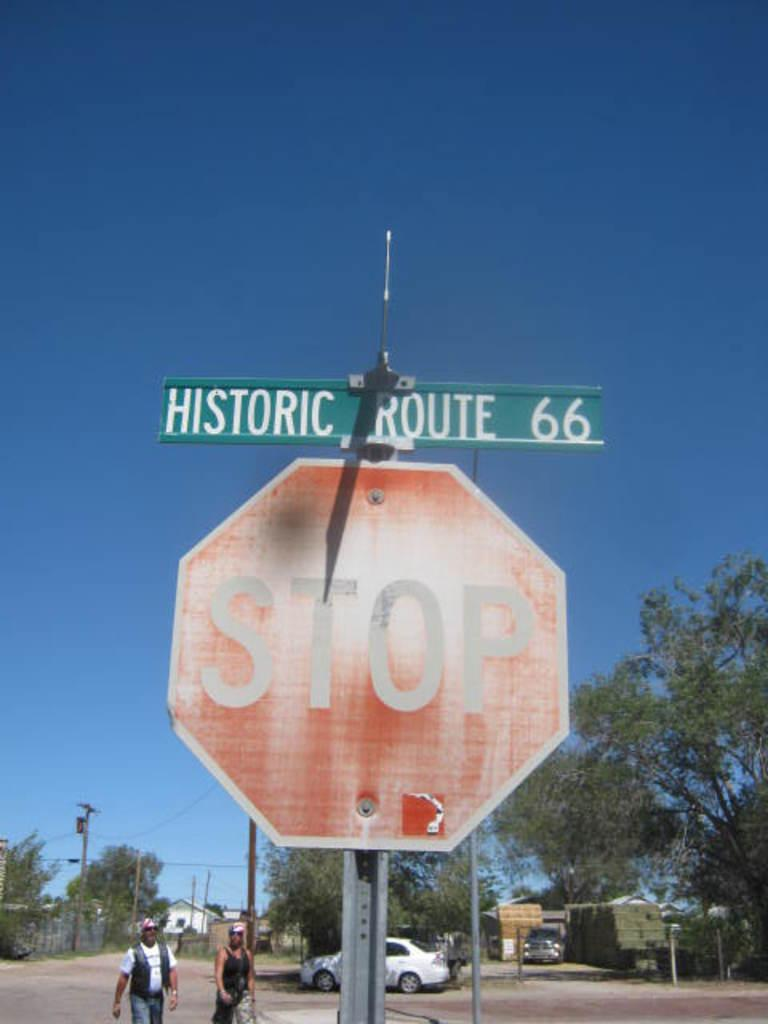<image>
Create a compact narrative representing the image presented. A stop sign with Historic Route 66 above it 